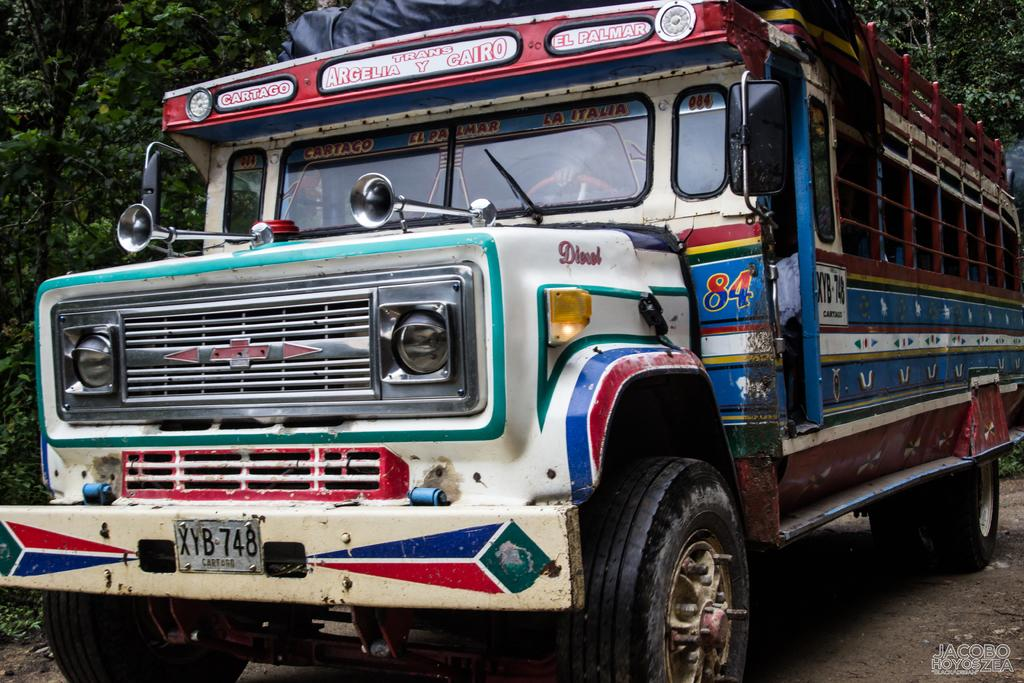What type of vehicle is in the image? There is a semi trailer truck in the image. Where is the truck located? The truck is on a pathway. Who is inside the truck? There is a person sitting inside the truck. What can be seen behind the truck? There is a group of trees visible on the backside of the truck. What color is the sun in the image? There is no sun present in the image. What does the person inside the truck use to smell things? The provided facts do not mention anything related to the person's nose. 